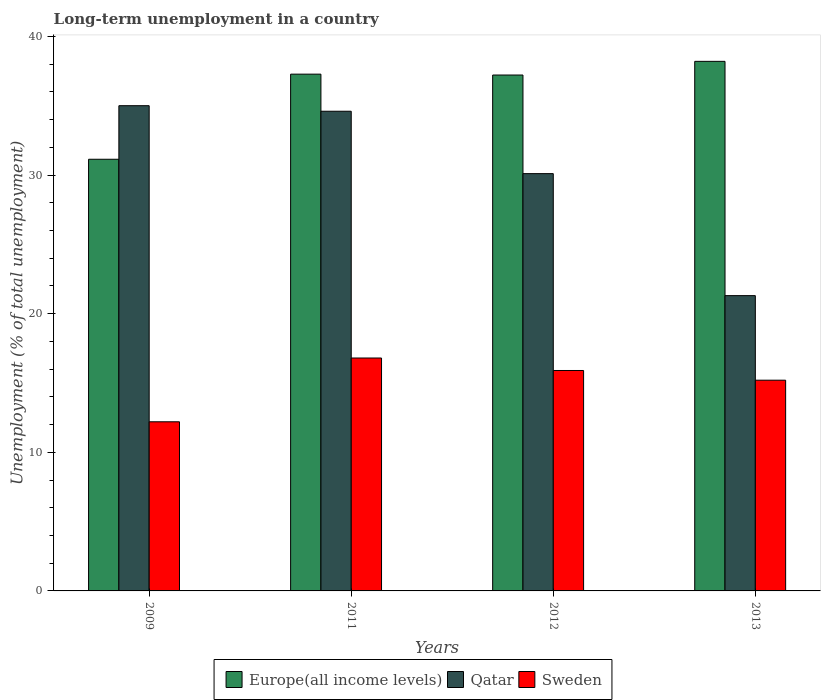How many different coloured bars are there?
Provide a succinct answer. 3. Are the number of bars on each tick of the X-axis equal?
Make the answer very short. Yes. What is the label of the 3rd group of bars from the left?
Your answer should be very brief. 2012. In how many cases, is the number of bars for a given year not equal to the number of legend labels?
Offer a very short reply. 0. What is the percentage of long-term unemployed population in Europe(all income levels) in 2013?
Your answer should be very brief. 38.2. Across all years, what is the maximum percentage of long-term unemployed population in Qatar?
Your response must be concise. 35. Across all years, what is the minimum percentage of long-term unemployed population in Sweden?
Give a very brief answer. 12.2. In which year was the percentage of long-term unemployed population in Sweden minimum?
Your answer should be very brief. 2009. What is the total percentage of long-term unemployed population in Europe(all income levels) in the graph?
Your response must be concise. 143.82. What is the difference between the percentage of long-term unemployed population in Qatar in 2011 and that in 2012?
Offer a terse response. 4.5. What is the difference between the percentage of long-term unemployed population in Europe(all income levels) in 2012 and the percentage of long-term unemployed population in Sweden in 2013?
Ensure brevity in your answer.  22.01. What is the average percentage of long-term unemployed population in Qatar per year?
Offer a terse response. 30.25. In the year 2009, what is the difference between the percentage of long-term unemployed population in Sweden and percentage of long-term unemployed population in Qatar?
Your response must be concise. -22.8. In how many years, is the percentage of long-term unemployed population in Europe(all income levels) greater than 12 %?
Offer a very short reply. 4. What is the ratio of the percentage of long-term unemployed population in Sweden in 2011 to that in 2012?
Offer a very short reply. 1.06. Is the percentage of long-term unemployed population in Qatar in 2011 less than that in 2012?
Keep it short and to the point. No. Is the difference between the percentage of long-term unemployed population in Sweden in 2012 and 2013 greater than the difference between the percentage of long-term unemployed population in Qatar in 2012 and 2013?
Give a very brief answer. No. What is the difference between the highest and the second highest percentage of long-term unemployed population in Europe(all income levels)?
Offer a terse response. 0.92. What is the difference between the highest and the lowest percentage of long-term unemployed population in Qatar?
Your answer should be compact. 13.7. In how many years, is the percentage of long-term unemployed population in Sweden greater than the average percentage of long-term unemployed population in Sweden taken over all years?
Keep it short and to the point. 3. Is the sum of the percentage of long-term unemployed population in Europe(all income levels) in 2011 and 2013 greater than the maximum percentage of long-term unemployed population in Sweden across all years?
Make the answer very short. Yes. What does the 1st bar from the left in 2013 represents?
Keep it short and to the point. Europe(all income levels). What does the 3rd bar from the right in 2012 represents?
Ensure brevity in your answer.  Europe(all income levels). Is it the case that in every year, the sum of the percentage of long-term unemployed population in Sweden and percentage of long-term unemployed population in Europe(all income levels) is greater than the percentage of long-term unemployed population in Qatar?
Offer a very short reply. Yes. How many years are there in the graph?
Your answer should be compact. 4. What is the difference between two consecutive major ticks on the Y-axis?
Provide a succinct answer. 10. Does the graph contain grids?
Offer a very short reply. No. Where does the legend appear in the graph?
Your answer should be very brief. Bottom center. How many legend labels are there?
Offer a terse response. 3. What is the title of the graph?
Provide a short and direct response. Long-term unemployment in a country. What is the label or title of the X-axis?
Give a very brief answer. Years. What is the label or title of the Y-axis?
Give a very brief answer. Unemployment (% of total unemployment). What is the Unemployment (% of total unemployment) in Europe(all income levels) in 2009?
Offer a terse response. 31.14. What is the Unemployment (% of total unemployment) of Qatar in 2009?
Provide a short and direct response. 35. What is the Unemployment (% of total unemployment) in Sweden in 2009?
Your answer should be very brief. 12.2. What is the Unemployment (% of total unemployment) of Europe(all income levels) in 2011?
Give a very brief answer. 37.28. What is the Unemployment (% of total unemployment) in Qatar in 2011?
Provide a succinct answer. 34.6. What is the Unemployment (% of total unemployment) in Sweden in 2011?
Ensure brevity in your answer.  16.8. What is the Unemployment (% of total unemployment) of Europe(all income levels) in 2012?
Your answer should be compact. 37.21. What is the Unemployment (% of total unemployment) in Qatar in 2012?
Keep it short and to the point. 30.1. What is the Unemployment (% of total unemployment) of Sweden in 2012?
Make the answer very short. 15.9. What is the Unemployment (% of total unemployment) in Europe(all income levels) in 2013?
Offer a terse response. 38.2. What is the Unemployment (% of total unemployment) in Qatar in 2013?
Your response must be concise. 21.3. What is the Unemployment (% of total unemployment) in Sweden in 2013?
Make the answer very short. 15.2. Across all years, what is the maximum Unemployment (% of total unemployment) of Europe(all income levels)?
Your answer should be compact. 38.2. Across all years, what is the maximum Unemployment (% of total unemployment) of Qatar?
Your answer should be compact. 35. Across all years, what is the maximum Unemployment (% of total unemployment) of Sweden?
Your answer should be very brief. 16.8. Across all years, what is the minimum Unemployment (% of total unemployment) in Europe(all income levels)?
Make the answer very short. 31.14. Across all years, what is the minimum Unemployment (% of total unemployment) of Qatar?
Give a very brief answer. 21.3. Across all years, what is the minimum Unemployment (% of total unemployment) in Sweden?
Provide a short and direct response. 12.2. What is the total Unemployment (% of total unemployment) in Europe(all income levels) in the graph?
Keep it short and to the point. 143.82. What is the total Unemployment (% of total unemployment) in Qatar in the graph?
Give a very brief answer. 121. What is the total Unemployment (% of total unemployment) in Sweden in the graph?
Keep it short and to the point. 60.1. What is the difference between the Unemployment (% of total unemployment) of Europe(all income levels) in 2009 and that in 2011?
Ensure brevity in your answer.  -6.14. What is the difference between the Unemployment (% of total unemployment) of Qatar in 2009 and that in 2011?
Your answer should be very brief. 0.4. What is the difference between the Unemployment (% of total unemployment) of Europe(all income levels) in 2009 and that in 2012?
Ensure brevity in your answer.  -6.08. What is the difference between the Unemployment (% of total unemployment) of Sweden in 2009 and that in 2012?
Your response must be concise. -3.7. What is the difference between the Unemployment (% of total unemployment) in Europe(all income levels) in 2009 and that in 2013?
Your answer should be compact. -7.06. What is the difference between the Unemployment (% of total unemployment) in Qatar in 2009 and that in 2013?
Provide a short and direct response. 13.7. What is the difference between the Unemployment (% of total unemployment) in Sweden in 2009 and that in 2013?
Ensure brevity in your answer.  -3. What is the difference between the Unemployment (% of total unemployment) in Europe(all income levels) in 2011 and that in 2012?
Your answer should be very brief. 0.06. What is the difference between the Unemployment (% of total unemployment) of Europe(all income levels) in 2011 and that in 2013?
Offer a very short reply. -0.92. What is the difference between the Unemployment (% of total unemployment) of Qatar in 2011 and that in 2013?
Your answer should be very brief. 13.3. What is the difference between the Unemployment (% of total unemployment) of Europe(all income levels) in 2012 and that in 2013?
Make the answer very short. -0.99. What is the difference between the Unemployment (% of total unemployment) of Qatar in 2012 and that in 2013?
Offer a very short reply. 8.8. What is the difference between the Unemployment (% of total unemployment) of Europe(all income levels) in 2009 and the Unemployment (% of total unemployment) of Qatar in 2011?
Provide a succinct answer. -3.46. What is the difference between the Unemployment (% of total unemployment) in Europe(all income levels) in 2009 and the Unemployment (% of total unemployment) in Sweden in 2011?
Your answer should be very brief. 14.34. What is the difference between the Unemployment (% of total unemployment) in Europe(all income levels) in 2009 and the Unemployment (% of total unemployment) in Qatar in 2012?
Make the answer very short. 1.04. What is the difference between the Unemployment (% of total unemployment) in Europe(all income levels) in 2009 and the Unemployment (% of total unemployment) in Sweden in 2012?
Provide a succinct answer. 15.24. What is the difference between the Unemployment (% of total unemployment) in Europe(all income levels) in 2009 and the Unemployment (% of total unemployment) in Qatar in 2013?
Ensure brevity in your answer.  9.84. What is the difference between the Unemployment (% of total unemployment) of Europe(all income levels) in 2009 and the Unemployment (% of total unemployment) of Sweden in 2013?
Your response must be concise. 15.94. What is the difference between the Unemployment (% of total unemployment) of Qatar in 2009 and the Unemployment (% of total unemployment) of Sweden in 2013?
Give a very brief answer. 19.8. What is the difference between the Unemployment (% of total unemployment) of Europe(all income levels) in 2011 and the Unemployment (% of total unemployment) of Qatar in 2012?
Your answer should be very brief. 7.18. What is the difference between the Unemployment (% of total unemployment) in Europe(all income levels) in 2011 and the Unemployment (% of total unemployment) in Sweden in 2012?
Make the answer very short. 21.38. What is the difference between the Unemployment (% of total unemployment) in Europe(all income levels) in 2011 and the Unemployment (% of total unemployment) in Qatar in 2013?
Keep it short and to the point. 15.98. What is the difference between the Unemployment (% of total unemployment) of Europe(all income levels) in 2011 and the Unemployment (% of total unemployment) of Sweden in 2013?
Provide a succinct answer. 22.08. What is the difference between the Unemployment (% of total unemployment) in Qatar in 2011 and the Unemployment (% of total unemployment) in Sweden in 2013?
Provide a short and direct response. 19.4. What is the difference between the Unemployment (% of total unemployment) in Europe(all income levels) in 2012 and the Unemployment (% of total unemployment) in Qatar in 2013?
Your answer should be compact. 15.91. What is the difference between the Unemployment (% of total unemployment) of Europe(all income levels) in 2012 and the Unemployment (% of total unemployment) of Sweden in 2013?
Offer a very short reply. 22.01. What is the difference between the Unemployment (% of total unemployment) in Qatar in 2012 and the Unemployment (% of total unemployment) in Sweden in 2013?
Make the answer very short. 14.9. What is the average Unemployment (% of total unemployment) of Europe(all income levels) per year?
Your answer should be compact. 35.96. What is the average Unemployment (% of total unemployment) in Qatar per year?
Your answer should be compact. 30.25. What is the average Unemployment (% of total unemployment) in Sweden per year?
Your response must be concise. 15.03. In the year 2009, what is the difference between the Unemployment (% of total unemployment) of Europe(all income levels) and Unemployment (% of total unemployment) of Qatar?
Give a very brief answer. -3.86. In the year 2009, what is the difference between the Unemployment (% of total unemployment) in Europe(all income levels) and Unemployment (% of total unemployment) in Sweden?
Give a very brief answer. 18.94. In the year 2009, what is the difference between the Unemployment (% of total unemployment) in Qatar and Unemployment (% of total unemployment) in Sweden?
Provide a succinct answer. 22.8. In the year 2011, what is the difference between the Unemployment (% of total unemployment) of Europe(all income levels) and Unemployment (% of total unemployment) of Qatar?
Keep it short and to the point. 2.68. In the year 2011, what is the difference between the Unemployment (% of total unemployment) of Europe(all income levels) and Unemployment (% of total unemployment) of Sweden?
Provide a short and direct response. 20.48. In the year 2012, what is the difference between the Unemployment (% of total unemployment) of Europe(all income levels) and Unemployment (% of total unemployment) of Qatar?
Offer a very short reply. 7.11. In the year 2012, what is the difference between the Unemployment (% of total unemployment) of Europe(all income levels) and Unemployment (% of total unemployment) of Sweden?
Ensure brevity in your answer.  21.31. In the year 2013, what is the difference between the Unemployment (% of total unemployment) in Europe(all income levels) and Unemployment (% of total unemployment) in Qatar?
Make the answer very short. 16.9. In the year 2013, what is the difference between the Unemployment (% of total unemployment) in Europe(all income levels) and Unemployment (% of total unemployment) in Sweden?
Offer a terse response. 23. In the year 2013, what is the difference between the Unemployment (% of total unemployment) of Qatar and Unemployment (% of total unemployment) of Sweden?
Offer a terse response. 6.1. What is the ratio of the Unemployment (% of total unemployment) of Europe(all income levels) in 2009 to that in 2011?
Keep it short and to the point. 0.84. What is the ratio of the Unemployment (% of total unemployment) of Qatar in 2009 to that in 2011?
Your response must be concise. 1.01. What is the ratio of the Unemployment (% of total unemployment) of Sweden in 2009 to that in 2011?
Your response must be concise. 0.73. What is the ratio of the Unemployment (% of total unemployment) in Europe(all income levels) in 2009 to that in 2012?
Keep it short and to the point. 0.84. What is the ratio of the Unemployment (% of total unemployment) of Qatar in 2009 to that in 2012?
Your response must be concise. 1.16. What is the ratio of the Unemployment (% of total unemployment) of Sweden in 2009 to that in 2012?
Give a very brief answer. 0.77. What is the ratio of the Unemployment (% of total unemployment) in Europe(all income levels) in 2009 to that in 2013?
Keep it short and to the point. 0.82. What is the ratio of the Unemployment (% of total unemployment) in Qatar in 2009 to that in 2013?
Give a very brief answer. 1.64. What is the ratio of the Unemployment (% of total unemployment) in Sweden in 2009 to that in 2013?
Your answer should be very brief. 0.8. What is the ratio of the Unemployment (% of total unemployment) in Europe(all income levels) in 2011 to that in 2012?
Make the answer very short. 1. What is the ratio of the Unemployment (% of total unemployment) of Qatar in 2011 to that in 2012?
Offer a very short reply. 1.15. What is the ratio of the Unemployment (% of total unemployment) in Sweden in 2011 to that in 2012?
Offer a terse response. 1.06. What is the ratio of the Unemployment (% of total unemployment) of Europe(all income levels) in 2011 to that in 2013?
Keep it short and to the point. 0.98. What is the ratio of the Unemployment (% of total unemployment) in Qatar in 2011 to that in 2013?
Give a very brief answer. 1.62. What is the ratio of the Unemployment (% of total unemployment) in Sweden in 2011 to that in 2013?
Keep it short and to the point. 1.11. What is the ratio of the Unemployment (% of total unemployment) in Europe(all income levels) in 2012 to that in 2013?
Your response must be concise. 0.97. What is the ratio of the Unemployment (% of total unemployment) in Qatar in 2012 to that in 2013?
Keep it short and to the point. 1.41. What is the ratio of the Unemployment (% of total unemployment) in Sweden in 2012 to that in 2013?
Provide a succinct answer. 1.05. What is the difference between the highest and the second highest Unemployment (% of total unemployment) in Europe(all income levels)?
Your answer should be compact. 0.92. What is the difference between the highest and the lowest Unemployment (% of total unemployment) of Europe(all income levels)?
Your response must be concise. 7.06. What is the difference between the highest and the lowest Unemployment (% of total unemployment) in Qatar?
Your answer should be compact. 13.7. What is the difference between the highest and the lowest Unemployment (% of total unemployment) in Sweden?
Provide a short and direct response. 4.6. 